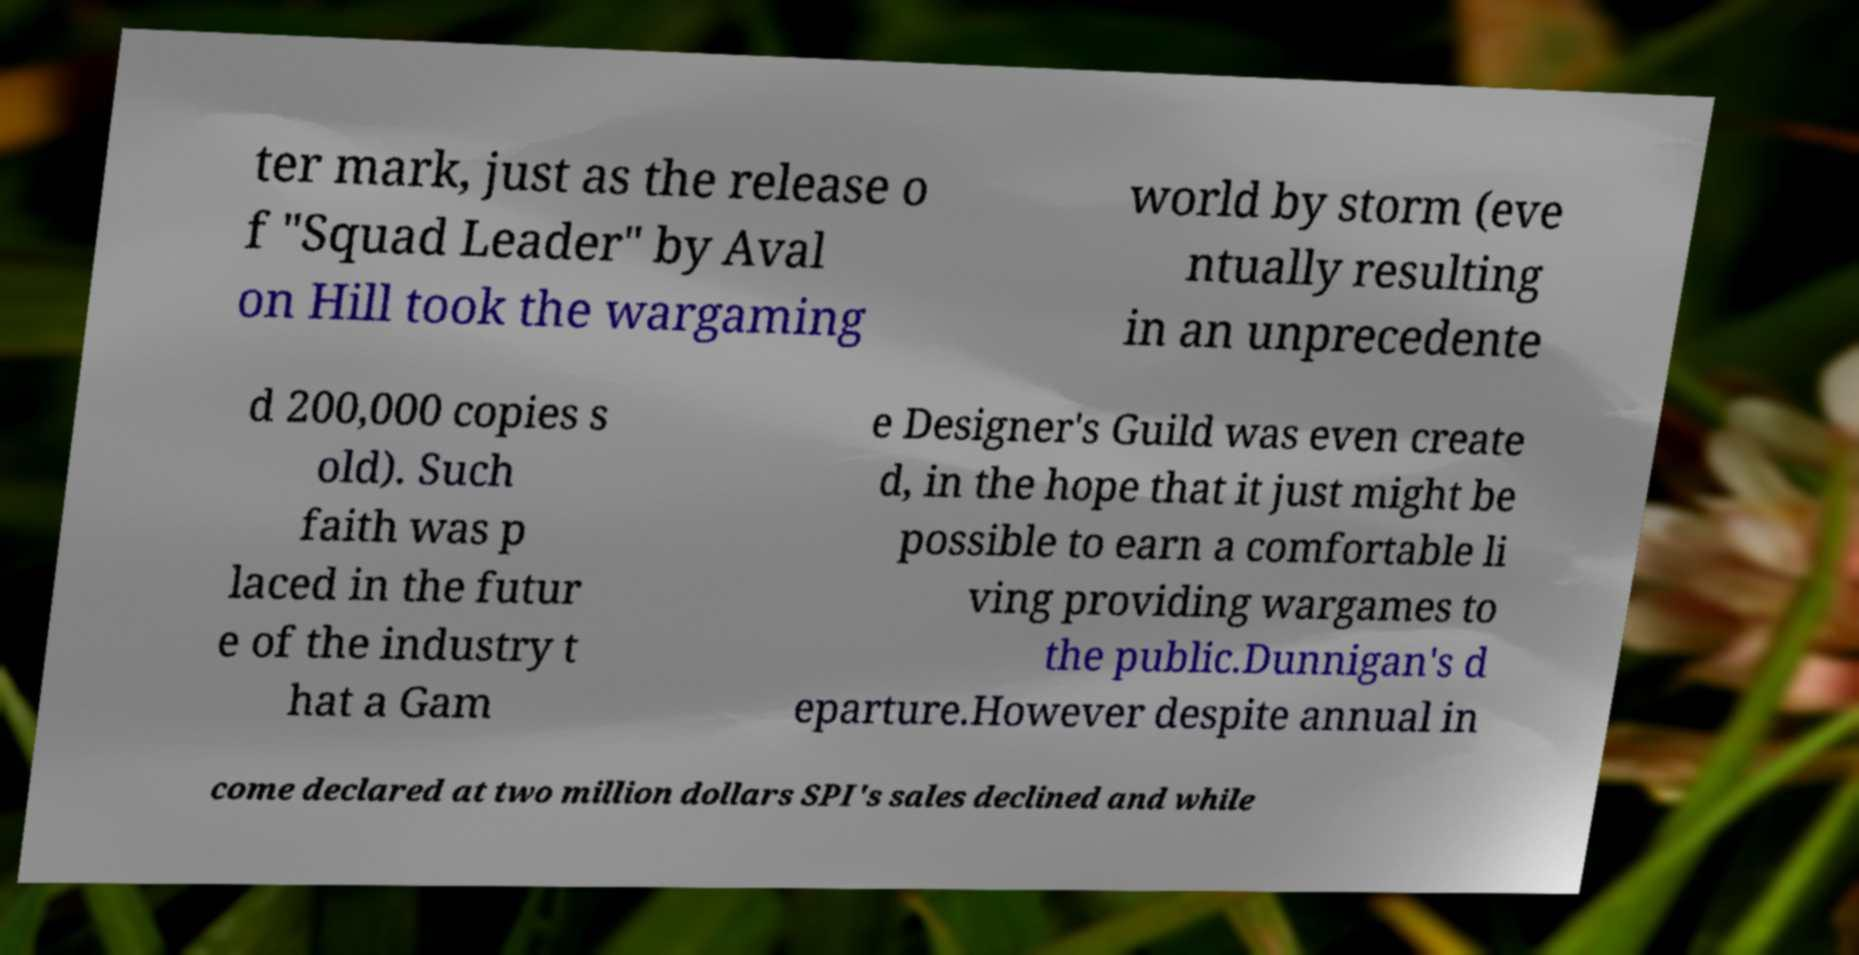What messages or text are displayed in this image? I need them in a readable, typed format. ter mark, just as the release o f "Squad Leader" by Aval on Hill took the wargaming world by storm (eve ntually resulting in an unprecedente d 200,000 copies s old). Such faith was p laced in the futur e of the industry t hat a Gam e Designer's Guild was even create d, in the hope that it just might be possible to earn a comfortable li ving providing wargames to the public.Dunnigan's d eparture.However despite annual in come declared at two million dollars SPI's sales declined and while 